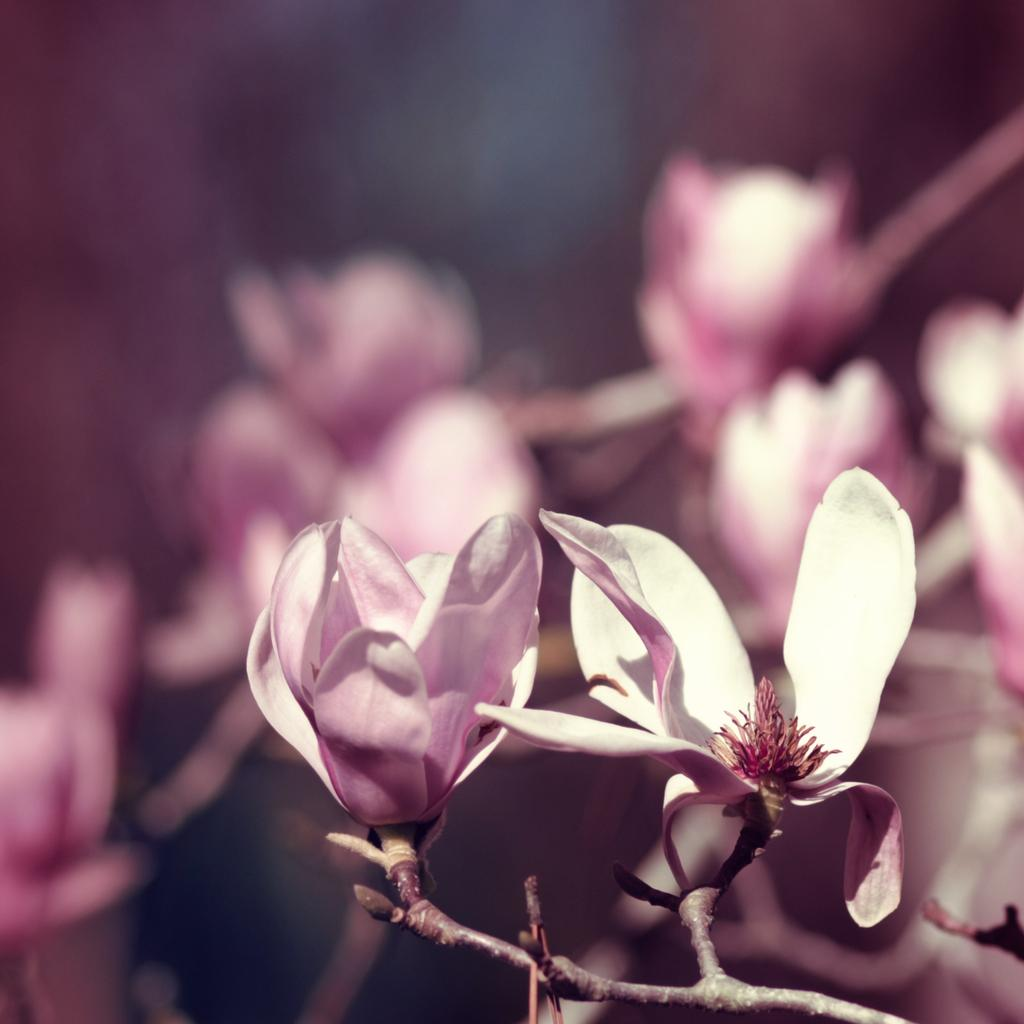What is the main subject of the image? The main subject of the image is branches with flowers. Can you describe the background of the image? The background of the image is blurred. What type of current can be seen flowing through the branches in the image? There is no current visible in the image; it features branches with flowers and a blurred background. What direction is the train traveling in the image? There is no train present in the image. 